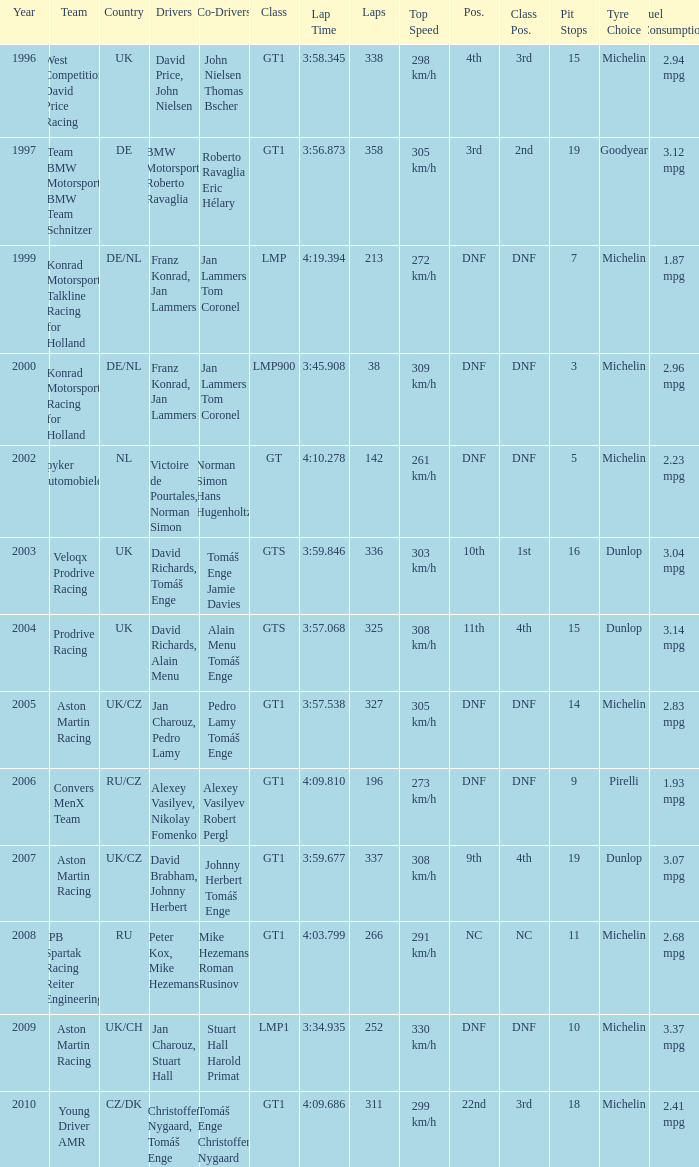Which team finished 3rd in class with 337 laps before 2008? West Competition David Price Racing. 